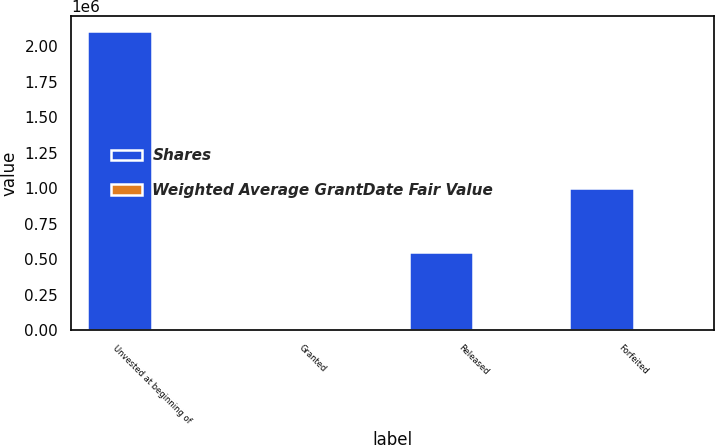Convert chart to OTSL. <chart><loc_0><loc_0><loc_500><loc_500><stacked_bar_chart><ecel><fcel>Unvested at beginning of<fcel>Granted<fcel>Released<fcel>Forfeited<nl><fcel>Shares<fcel>2.10733e+06<fcel>29.23<fcel>548510<fcel>1.00423e+06<nl><fcel>Weighted Average GrantDate Fair Value<fcel>20.01<fcel>29.23<fcel>22<fcel>22.98<nl></chart> 